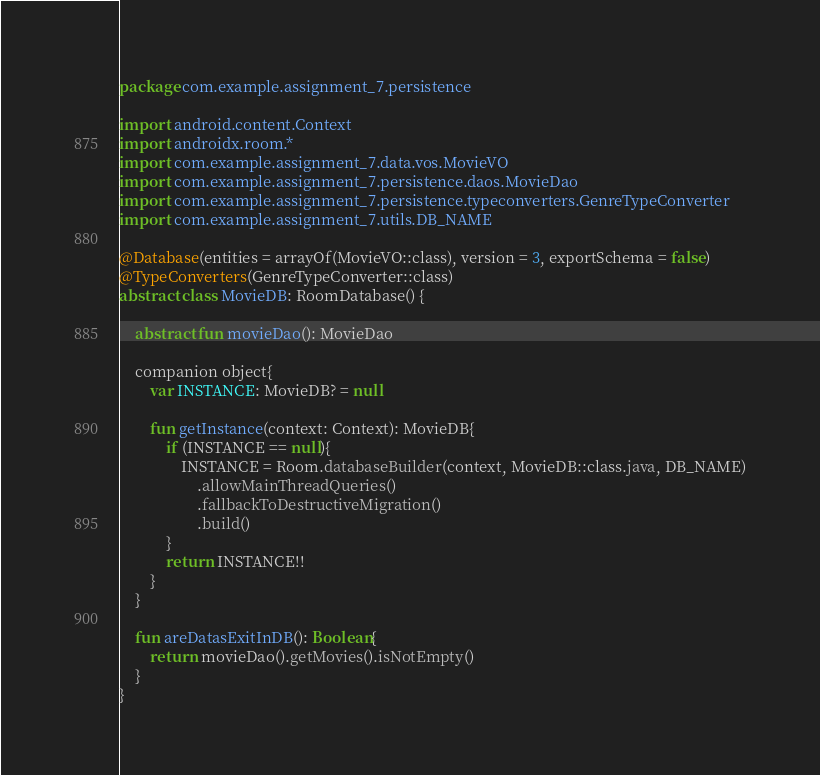Convert code to text. <code><loc_0><loc_0><loc_500><loc_500><_Kotlin_>package com.example.assignment_7.persistence

import android.content.Context
import androidx.room.*
import com.example.assignment_7.data.vos.MovieVO
import com.example.assignment_7.persistence.daos.MovieDao
import com.example.assignment_7.persistence.typeconverters.GenreTypeConverter
import com.example.assignment_7.utils.DB_NAME

@Database(entities = arrayOf(MovieVO::class), version = 3, exportSchema = false)
@TypeConverters(GenreTypeConverter::class)
abstract class MovieDB: RoomDatabase() {

    abstract fun movieDao(): MovieDao

    companion object{
        var INSTANCE: MovieDB? = null

        fun getInstance(context: Context): MovieDB{
            if (INSTANCE == null){
                INSTANCE = Room.databaseBuilder(context, MovieDB::class.java, DB_NAME)
                    .allowMainThreadQueries()
                    .fallbackToDestructiveMigration()
                    .build()
            }
            return INSTANCE!!
        }
    }

    fun areDatasExitInDB(): Boolean{
        return movieDao().getMovies().isNotEmpty()
    }
}</code> 